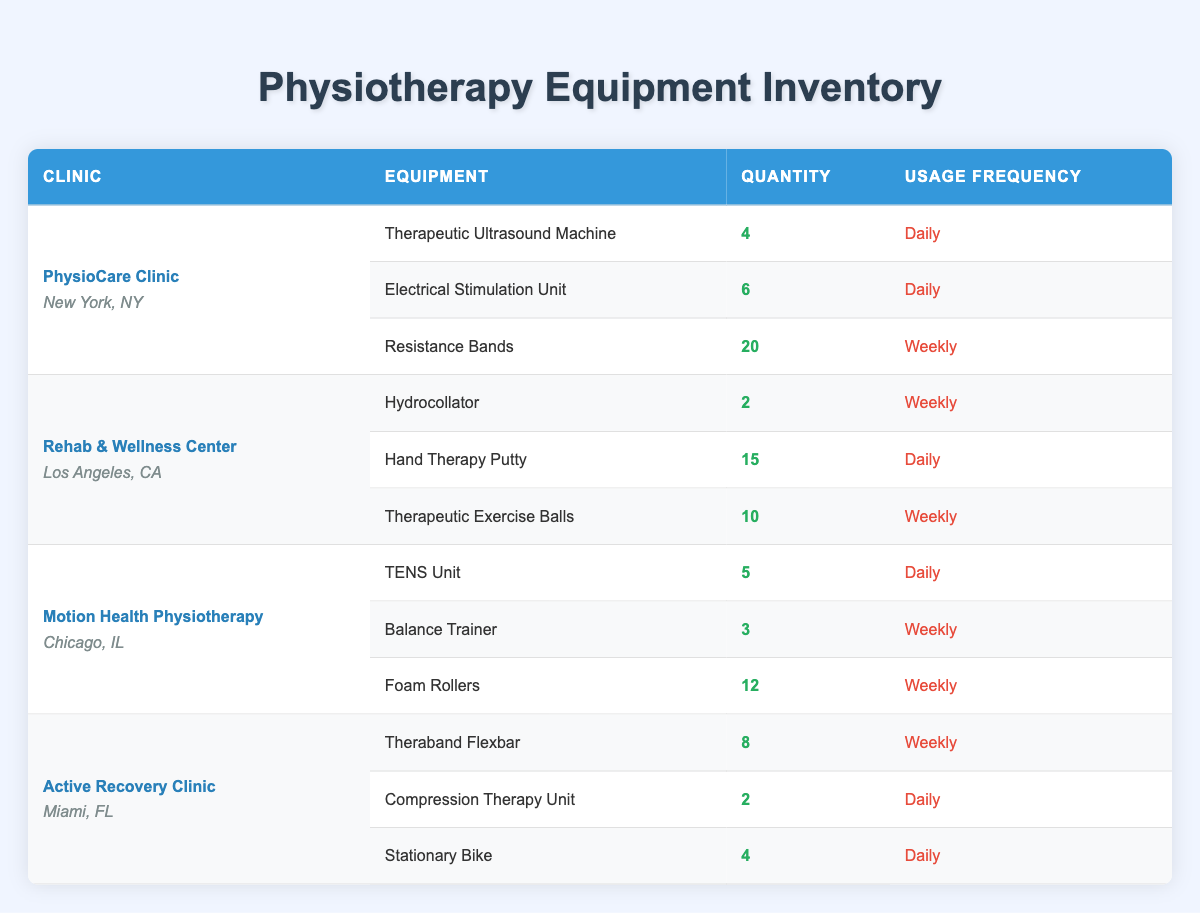What is the total quantity of equipment at the PhysioCare Clinic? To find the total quantity of equipment at PhysioCare Clinic, we need to sum the quantities of the listed equipment: 4 (Therapeutic Ultrasound Machine) + 6 (Electrical Stimulation Unit) + 20 (Resistance Bands) = 30.
Answer: 30 Which clinic has the highest quantity of equipment overall? We need to compare the total quantities of equipment at each clinic: PhysioCare Clinic = 30, Rehab & Wellness Center = 27 (2 + 15 + 10), Motion Health Physiotherapy = 20 (5 + 3 + 12), Active Recovery Clinic = 14 (8 + 2 + 4). PhysioCare Clinic has the highest total with 30.
Answer: PhysioCare Clinic Does the Active Recovery Clinic have any equipment with daily usage frequency? By looking at the Active Recovery Clinic, we see that both the Compression Therapy Unit and Stationary Bike have a daily usage frequency. Therefore, the answer is yes.
Answer: Yes What is the average quantity of equipment that is used daily across all clinics? We first add the quantities of daily-use equipment: 4 (PhysioCare) + 6 (PhysioCare) + 15 (Rehab) + 5 (Motion Health) + 2 (Active Recovery) + 4 (Active Recovery) = 36. There are 6 pieces of daily-use equipment, so the average is 36 / 6 = 6.
Answer: 6 Which clinic has the fewest total pieces of equipment, and how many do they have? Checking the total equipment quantities: PhysioCare Clinic = 30, Rehab & Wellness Center = 27, Motion Health Physiotherapy = 20, Active Recovery Clinic = 14. The Active Recovery Clinic has the least with 14 pieces of equipment.
Answer: Active Recovery Clinic, 14 Are Resistance Bands used daily at the PhysioCare Clinic? At the PhysioCare Clinic, Resistance Bands are specified as having a weekly usage frequency, which makes the answer no.
Answer: No How many types of equipment are used weekly at the Motion Health Physiotherapy clinic? From the Motion Health Physiotherapy clinic’s inventory, there are 3 types of equipment, but only the Balance Trainer and Foam Rollers are used weekly (the TENS Unit is daily). Thus, there are 2 types used weekly.
Answer: 2 What equipment does the Rehab & Wellness Center use that is not used daily? In the Rehab & Wellness Center, the Hydrocollator and Therapeutic Exercise Balls are used weekly. Both of these pieces of equipment do not have a daily usage frequency, only the Hand Therapy Putty is used daily, making Hydrocollator and Therapeutic Exercise Balls the answer.
Answer: Hydrocollator, Therapeutic Exercise Balls 